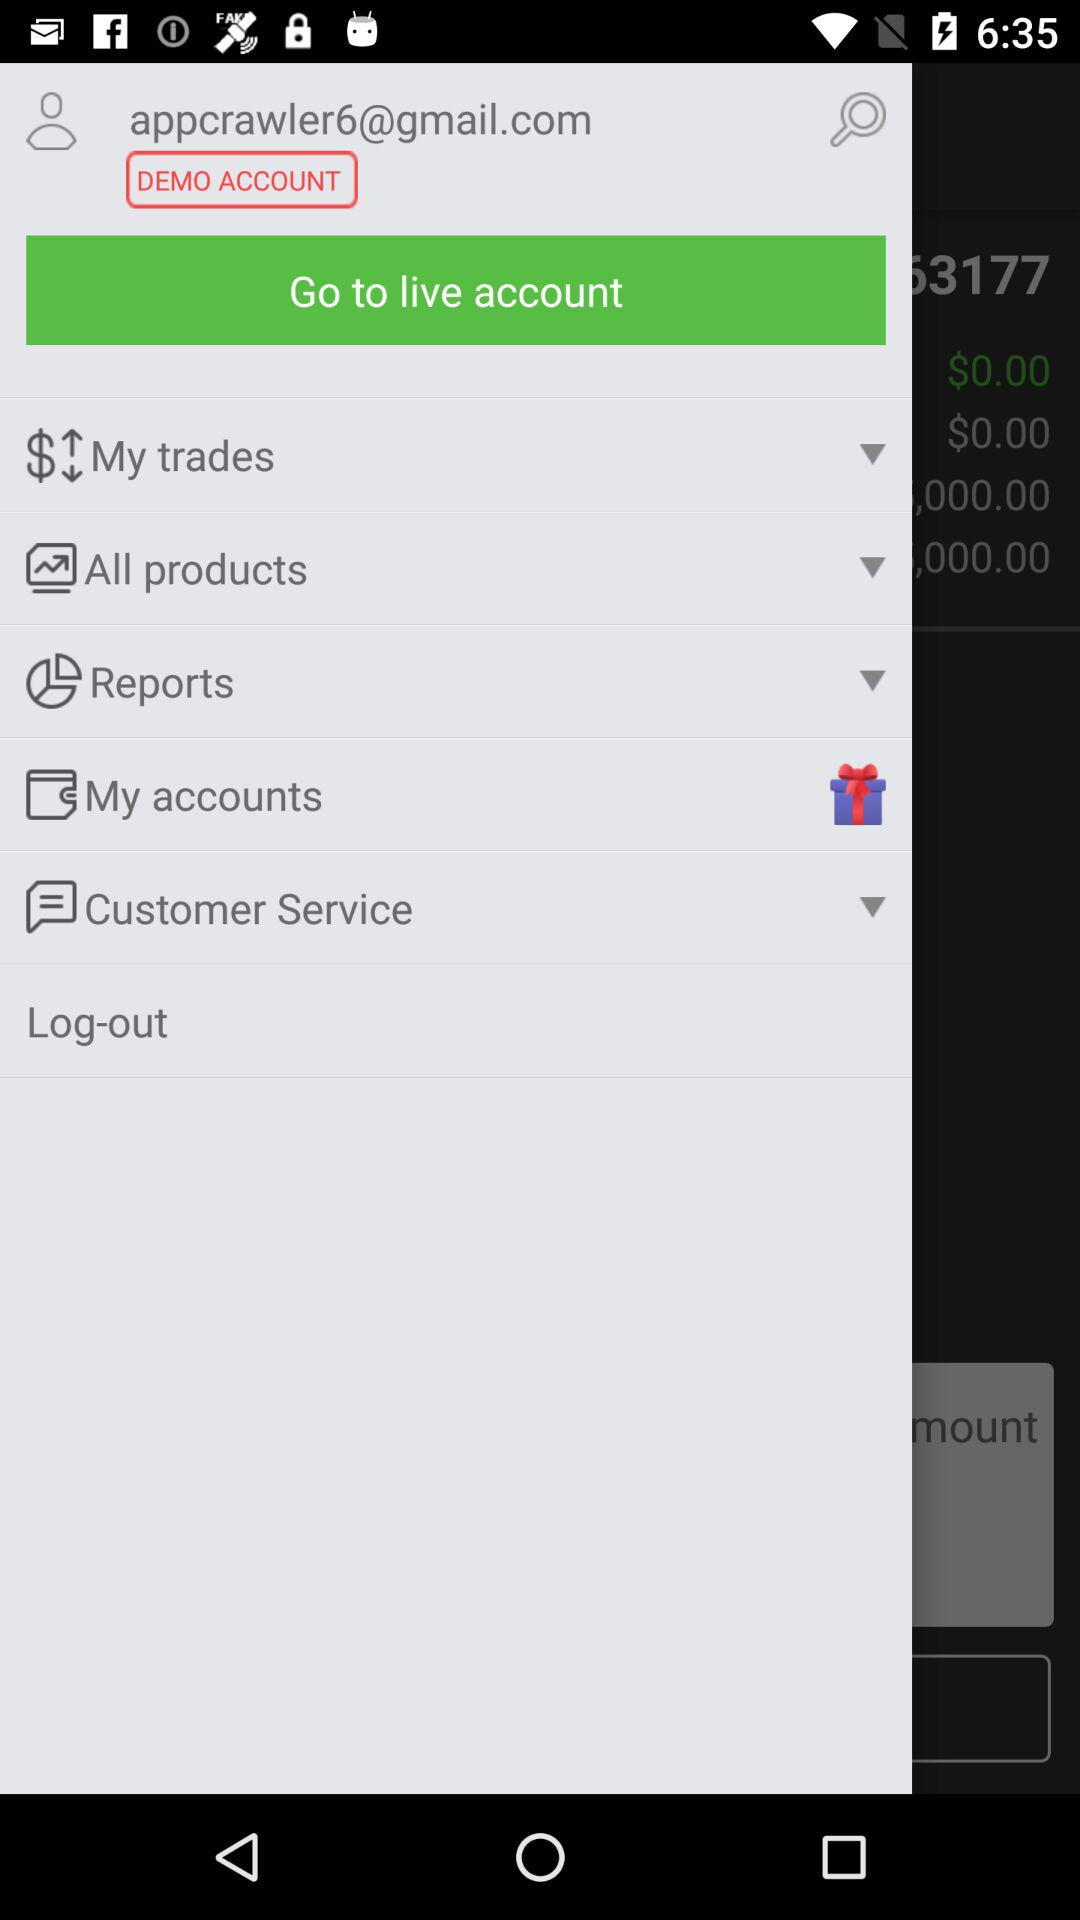What is the email address? The email address is appcrawler6@gmail.com. 